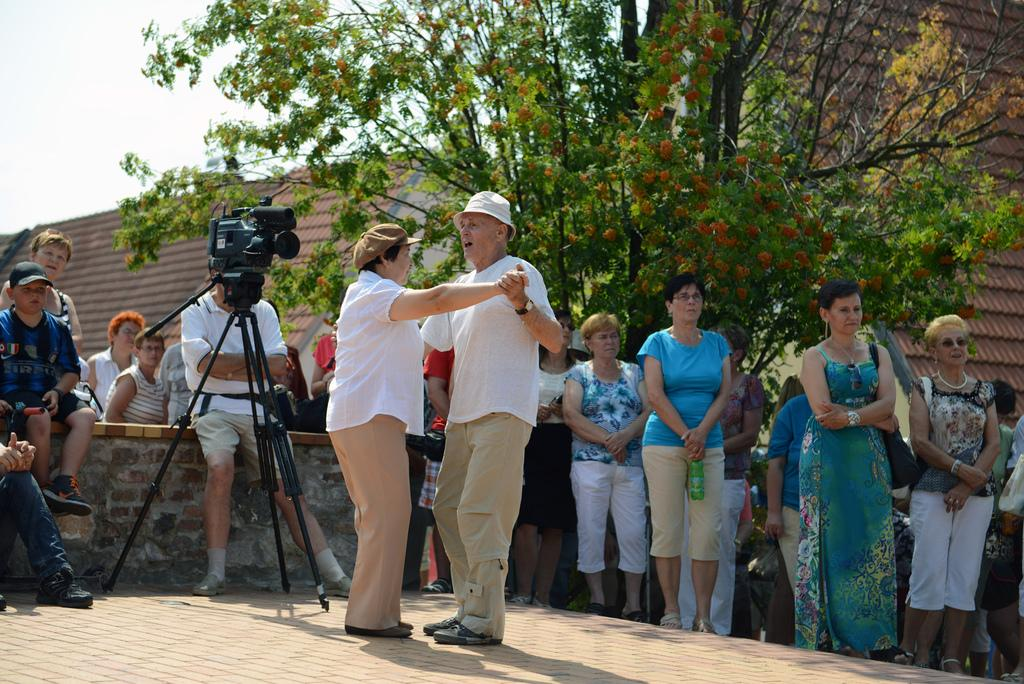What are the main subjects in the image? There is a couple dancing in the image. What equipment is used for capturing the scene? A camera is placed on a stand in the image. What can be seen in the background of the image? There are people, a tree, and buildings in the background of the image. What type of quilt is being used to cover the baby in the image? There is no quilt or baby present in the image; it features a couple dancing and a camera on a stand. What scientific theory is being discussed by the people in the background of the image? There is no indication of any scientific theory being discussed in the image; it only shows people in the background. 